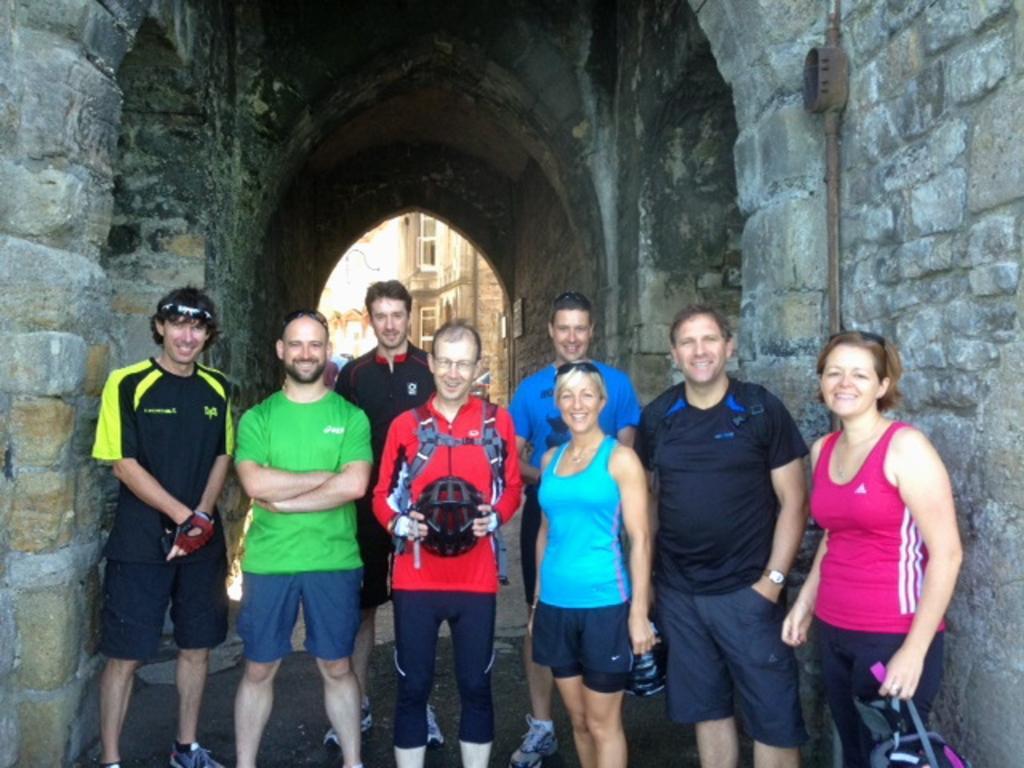Could you give a brief overview of what you see in this image? In the foreground of the picture there are people. In the picture we can see a construction made up of stones. In the center of the background there are buildings and people. 